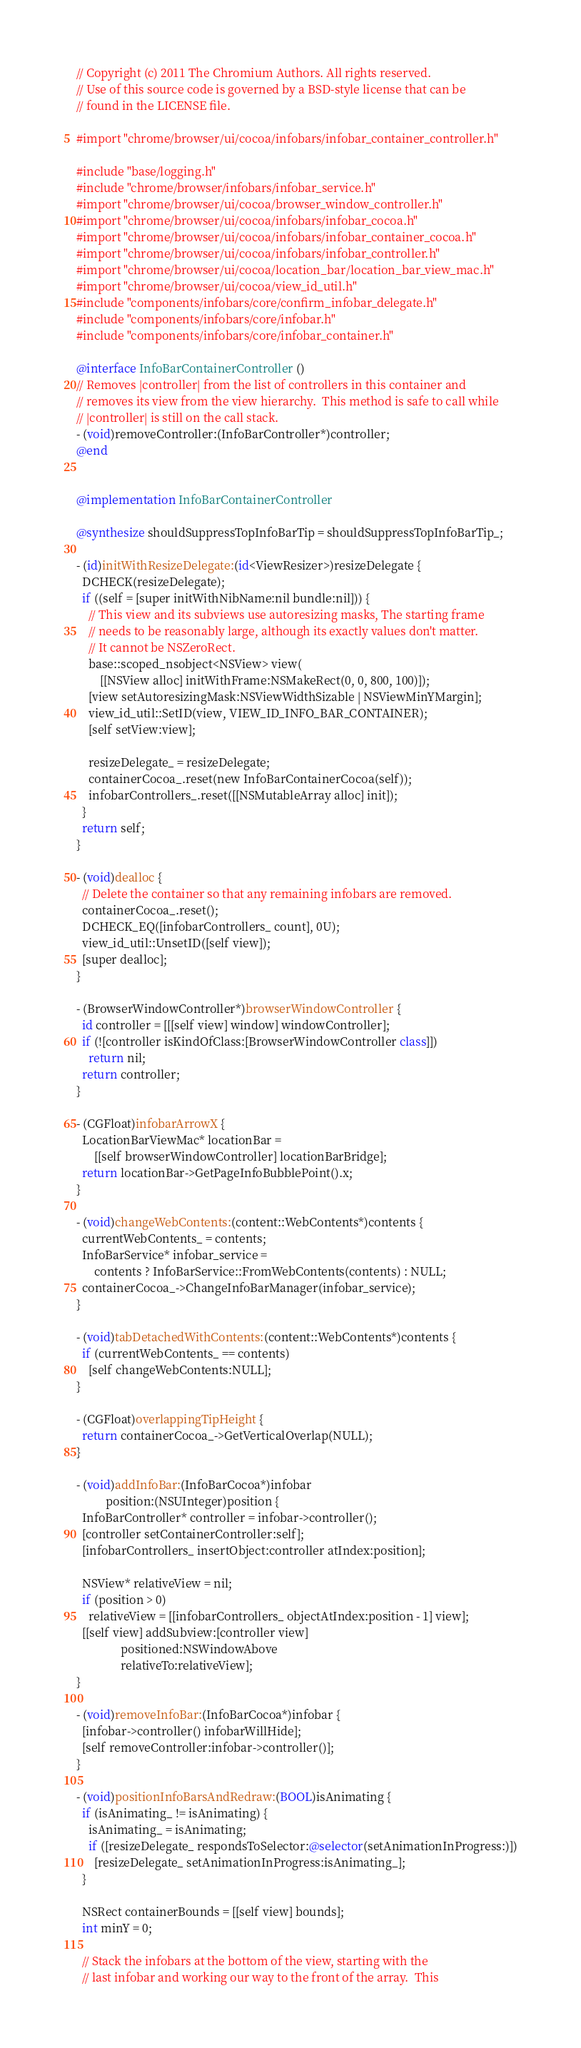Convert code to text. <code><loc_0><loc_0><loc_500><loc_500><_ObjectiveC_>// Copyright (c) 2011 The Chromium Authors. All rights reserved.
// Use of this source code is governed by a BSD-style license that can be
// found in the LICENSE file.

#import "chrome/browser/ui/cocoa/infobars/infobar_container_controller.h"

#include "base/logging.h"
#include "chrome/browser/infobars/infobar_service.h"
#import "chrome/browser/ui/cocoa/browser_window_controller.h"
#import "chrome/browser/ui/cocoa/infobars/infobar_cocoa.h"
#import "chrome/browser/ui/cocoa/infobars/infobar_container_cocoa.h"
#import "chrome/browser/ui/cocoa/infobars/infobar_controller.h"
#import "chrome/browser/ui/cocoa/location_bar/location_bar_view_mac.h"
#import "chrome/browser/ui/cocoa/view_id_util.h"
#include "components/infobars/core/confirm_infobar_delegate.h"
#include "components/infobars/core/infobar.h"
#include "components/infobars/core/infobar_container.h"

@interface InfoBarContainerController ()
// Removes |controller| from the list of controllers in this container and
// removes its view from the view hierarchy.  This method is safe to call while
// |controller| is still on the call stack.
- (void)removeController:(InfoBarController*)controller;
@end


@implementation InfoBarContainerController

@synthesize shouldSuppressTopInfoBarTip = shouldSuppressTopInfoBarTip_;

- (id)initWithResizeDelegate:(id<ViewResizer>)resizeDelegate {
  DCHECK(resizeDelegate);
  if ((self = [super initWithNibName:nil bundle:nil])) {
    // This view and its subviews use autoresizing masks, The starting frame
    // needs to be reasonably large, although its exactly values don't matter.
    // It cannot be NSZeroRect.
    base::scoped_nsobject<NSView> view(
        [[NSView alloc] initWithFrame:NSMakeRect(0, 0, 800, 100)]);
    [view setAutoresizingMask:NSViewWidthSizable | NSViewMinYMargin];
    view_id_util::SetID(view, VIEW_ID_INFO_BAR_CONTAINER);
    [self setView:view];

    resizeDelegate_ = resizeDelegate;
    containerCocoa_.reset(new InfoBarContainerCocoa(self));
    infobarControllers_.reset([[NSMutableArray alloc] init]);
  }
  return self;
}

- (void)dealloc {
  // Delete the container so that any remaining infobars are removed.
  containerCocoa_.reset();
  DCHECK_EQ([infobarControllers_ count], 0U);
  view_id_util::UnsetID([self view]);
  [super dealloc];
}

- (BrowserWindowController*)browserWindowController {
  id controller = [[[self view] window] windowController];
  if (![controller isKindOfClass:[BrowserWindowController class]])
    return nil;
  return controller;
}

- (CGFloat)infobarArrowX {
  LocationBarViewMac* locationBar =
      [[self browserWindowController] locationBarBridge];
  return locationBar->GetPageInfoBubblePoint().x;
}

- (void)changeWebContents:(content::WebContents*)contents {
  currentWebContents_ = contents;
  InfoBarService* infobar_service =
      contents ? InfoBarService::FromWebContents(contents) : NULL;
  containerCocoa_->ChangeInfoBarManager(infobar_service);
}

- (void)tabDetachedWithContents:(content::WebContents*)contents {
  if (currentWebContents_ == contents)
    [self changeWebContents:NULL];
}

- (CGFloat)overlappingTipHeight {
  return containerCocoa_->GetVerticalOverlap(NULL);
}

- (void)addInfoBar:(InfoBarCocoa*)infobar
          position:(NSUInteger)position {
  InfoBarController* controller = infobar->controller();
  [controller setContainerController:self];
  [infobarControllers_ insertObject:controller atIndex:position];

  NSView* relativeView = nil;
  if (position > 0)
    relativeView = [[infobarControllers_ objectAtIndex:position - 1] view];
  [[self view] addSubview:[controller view]
               positioned:NSWindowAbove
               relativeTo:relativeView];
}

- (void)removeInfoBar:(InfoBarCocoa*)infobar {
  [infobar->controller() infobarWillHide];
  [self removeController:infobar->controller()];
}

- (void)positionInfoBarsAndRedraw:(BOOL)isAnimating {
  if (isAnimating_ != isAnimating) {
    isAnimating_ = isAnimating;
    if ([resizeDelegate_ respondsToSelector:@selector(setAnimationInProgress:)])
      [resizeDelegate_ setAnimationInProgress:isAnimating_];
  }

  NSRect containerBounds = [[self view] bounds];
  int minY = 0;

  // Stack the infobars at the bottom of the view, starting with the
  // last infobar and working our way to the front of the array.  This</code> 